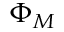Convert formula to latex. <formula><loc_0><loc_0><loc_500><loc_500>\Phi _ { M }</formula> 